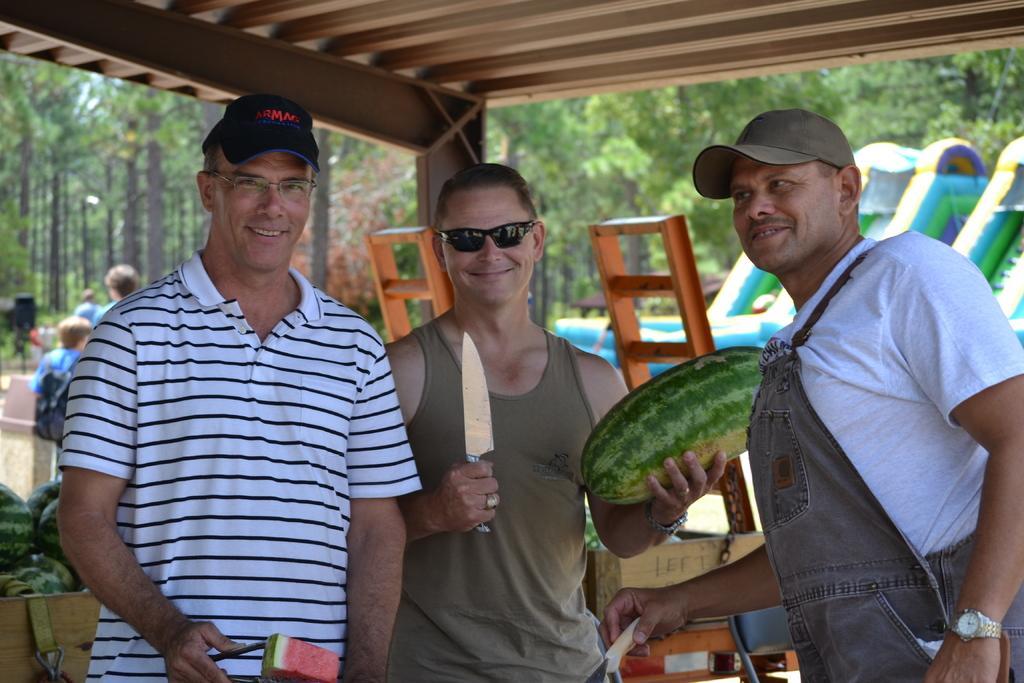Describe this image in one or two sentences. In this image I can see three men are standing in the front and I can see smile on their faces. I can see the middle one is holding a knife and a watermelon. In the background I can see number of trees, few more people and few watermelons. In the front I can see two men are wearing caps. 